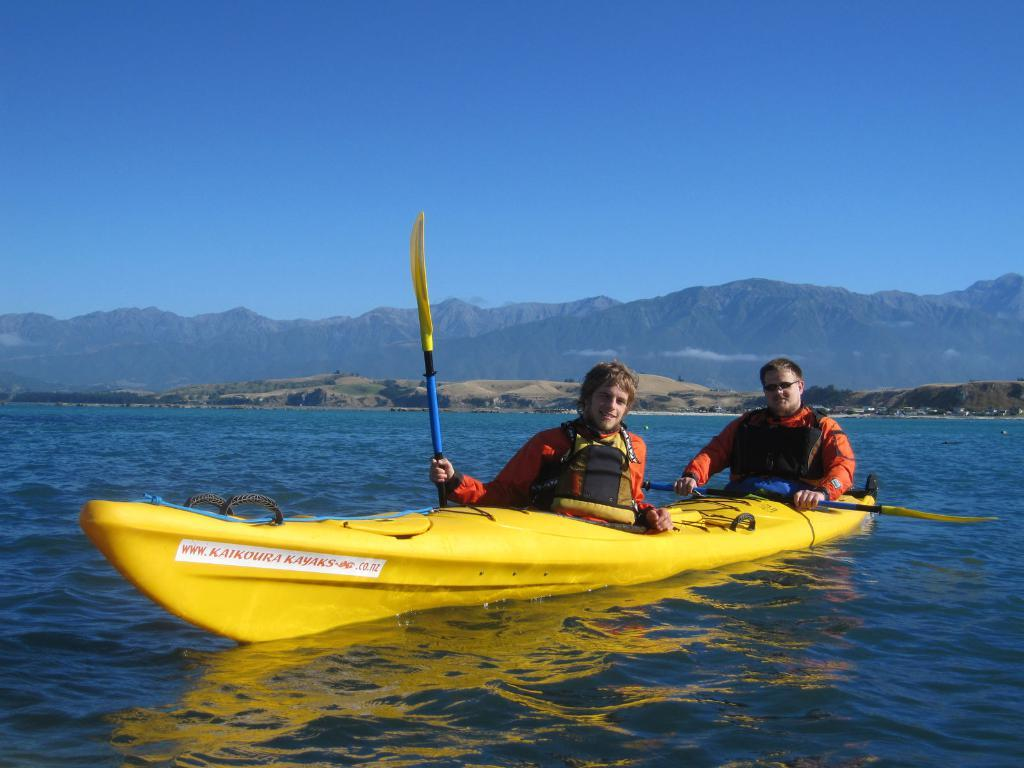What can be seen in the image? There are men in the image, and they are sitting on a kayak boat. What are the men doing while sitting on the kayak boat? The men are holding rows in their hands. What can be seen in the background of the image? There are hills, mountains, and the sky visible in the background of the image. What song is the men singing while rowing in the image? There is no indication in the image that the men are singing a song, so it cannot be determined from the picture. 